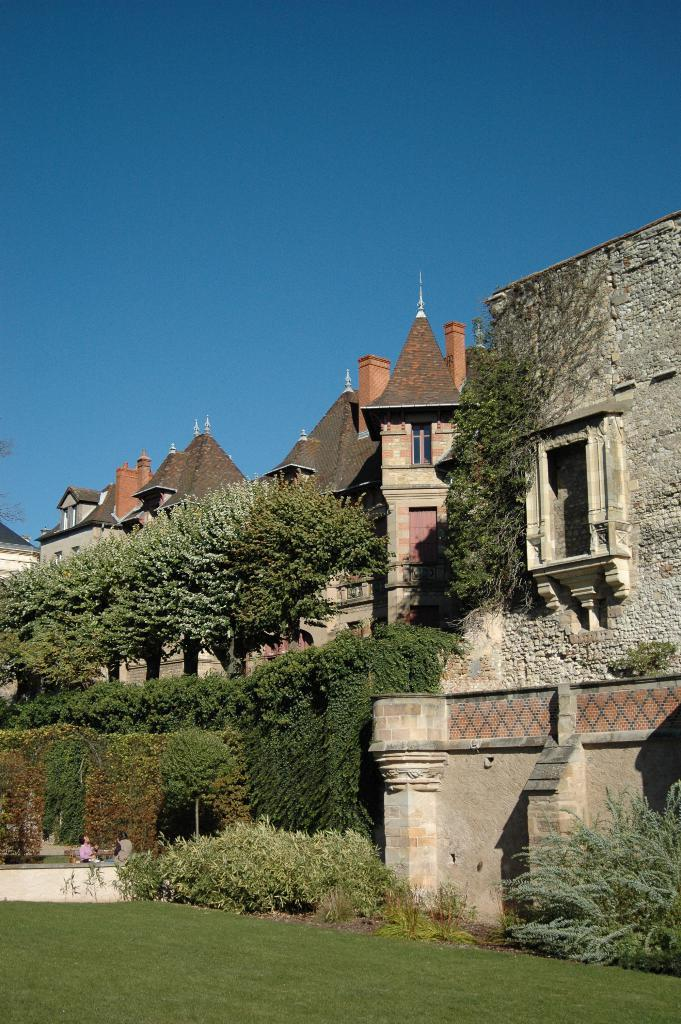What type of vegetation can be seen in the image? There is grass and trees in the image. What type of structures are visible in the image? There are houses in the image. What color is the sky in the background of the image? The sky is blue in the background of the image. Where is the lunchroom located in the image? There is no lunchroom present in the image. What industry is depicted in the image? There is no industry depicted in the image; it features grass, trees, houses, and a blue sky. 